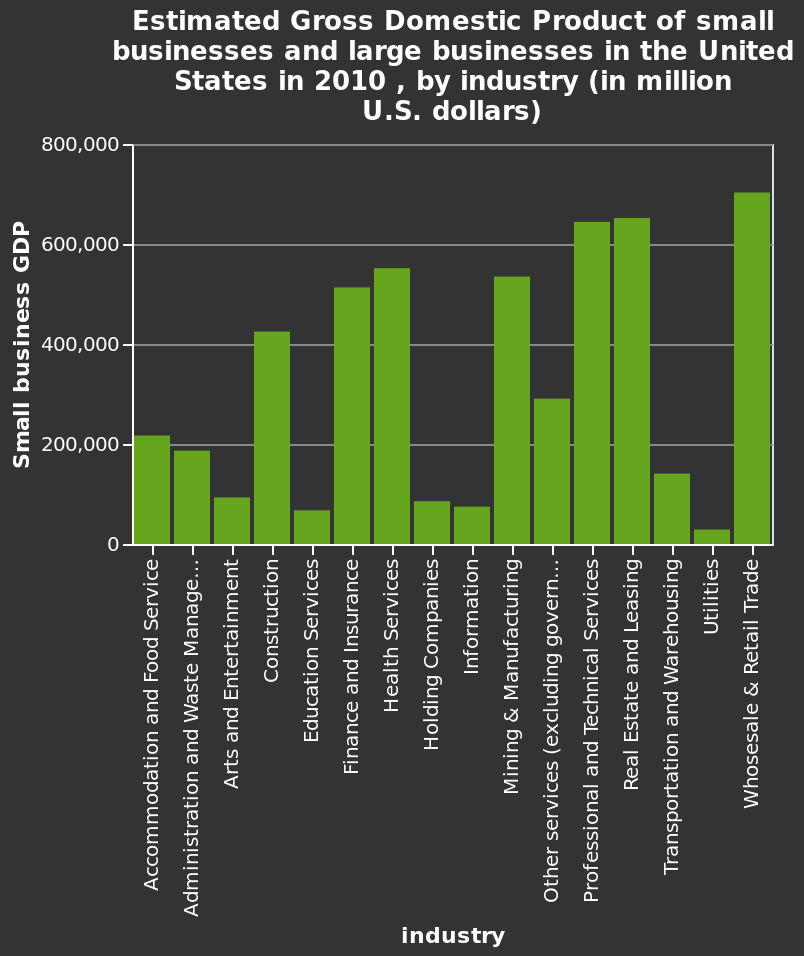<image>
Why does the wholesale and retail trade sector have a high GDP? The sector involves a significant amount of economic activity, with the buying and selling of goods contributing to a large portion of the overall economy. What unit is used to measure GDP in the bar diagram? GDP is measured in million U.S. dollars. 